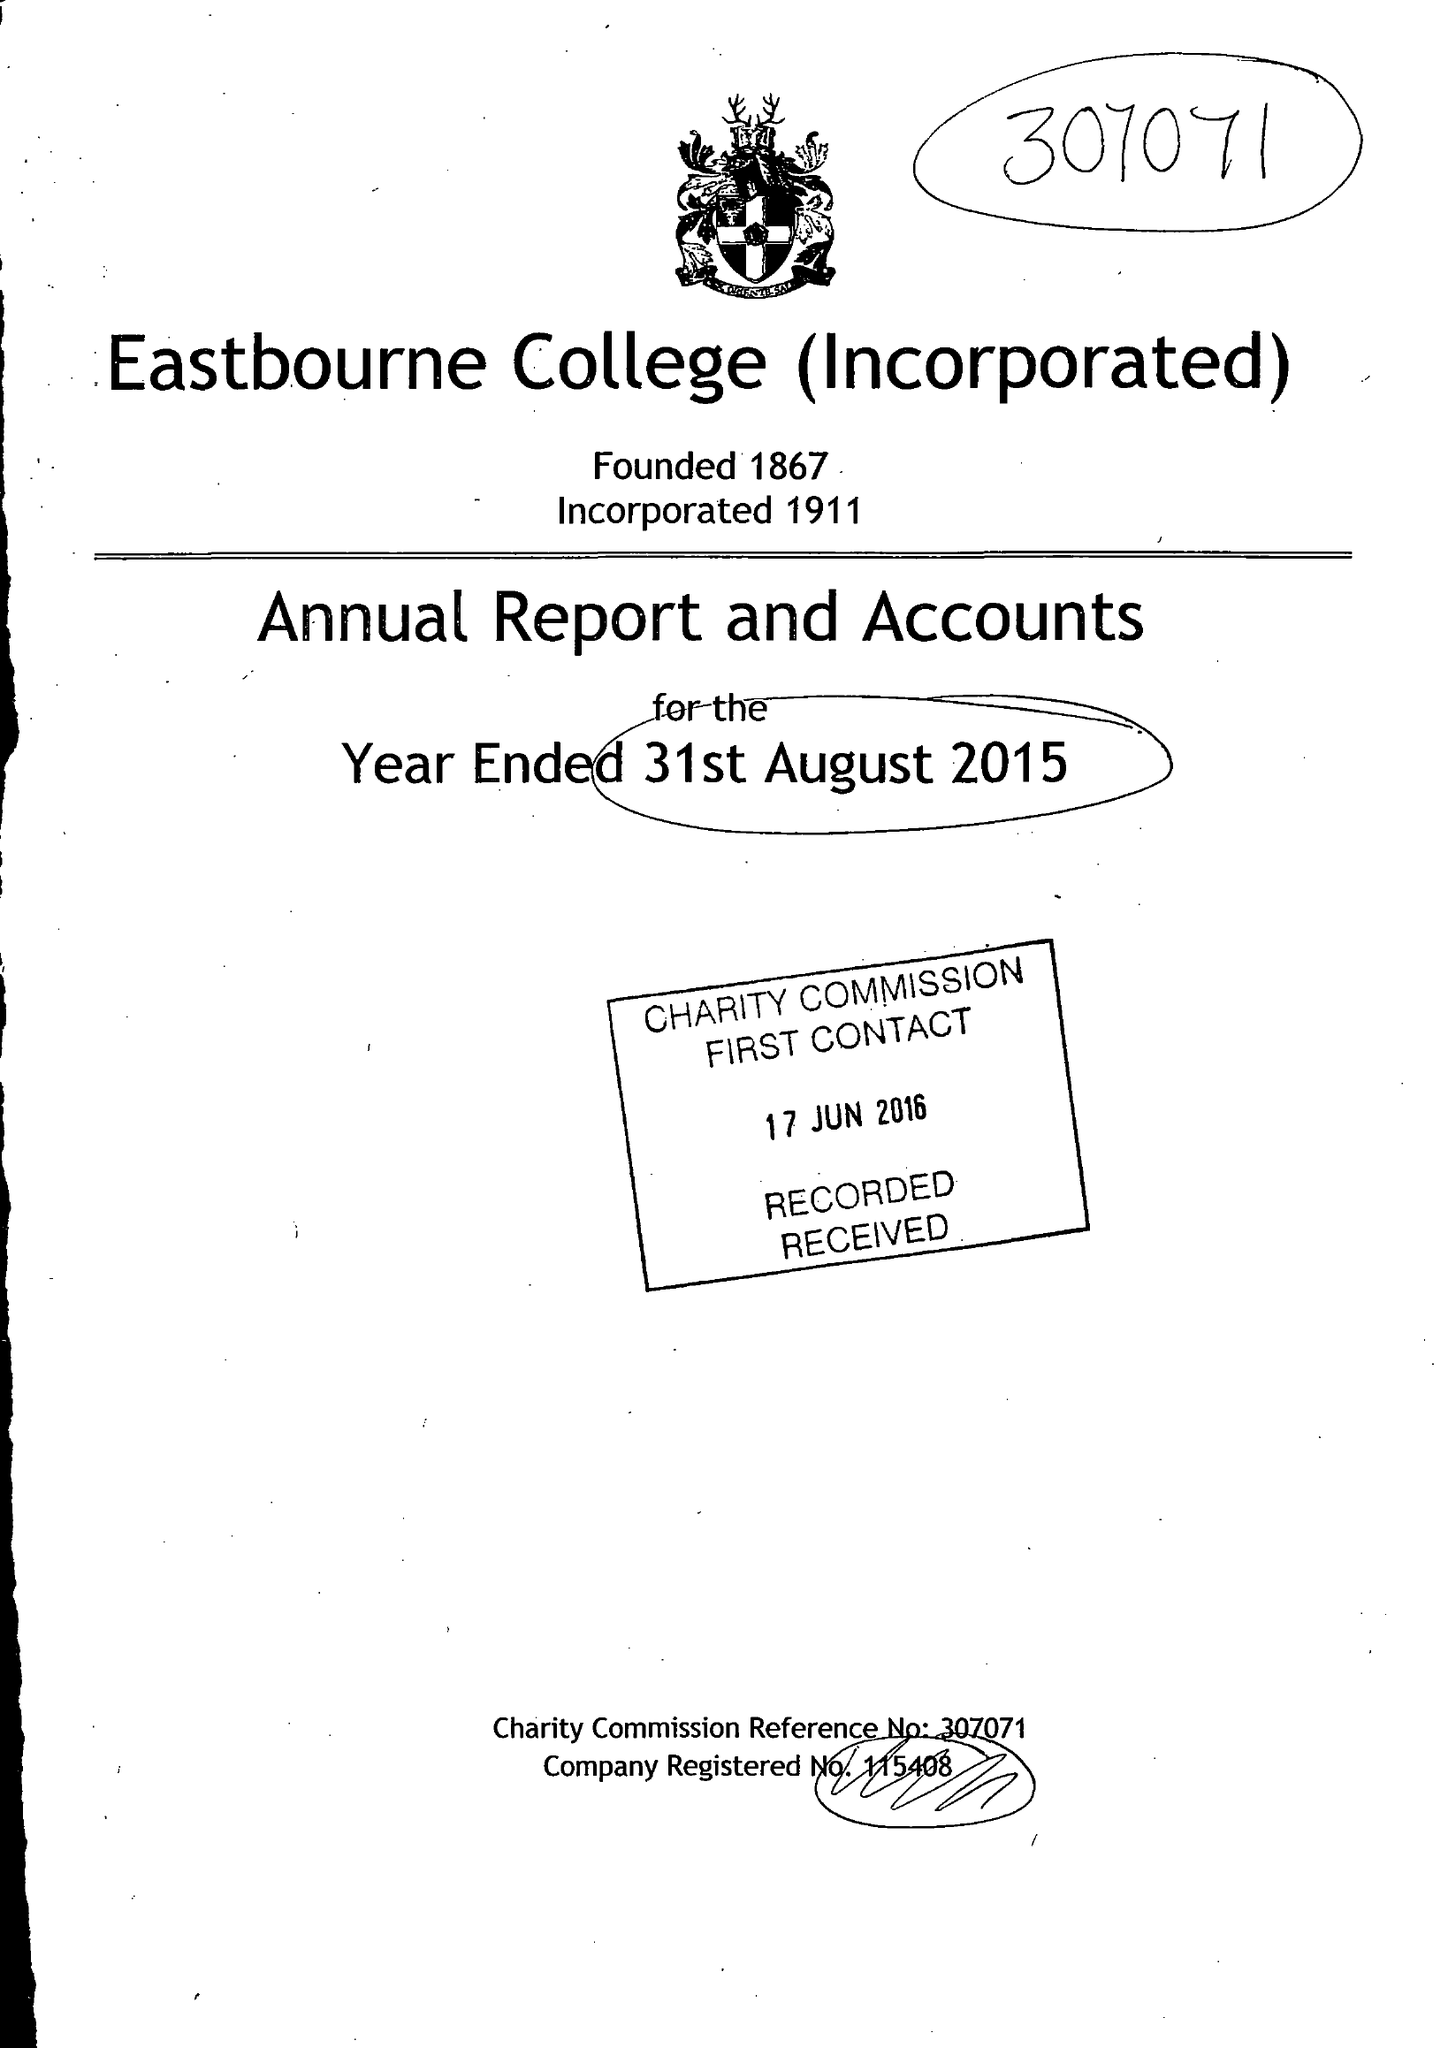What is the value for the report_date?
Answer the question using a single word or phrase. 2015-08-31 